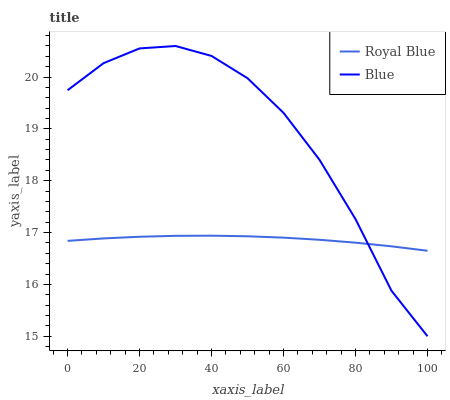Does Royal Blue have the minimum area under the curve?
Answer yes or no. Yes. Does Blue have the maximum area under the curve?
Answer yes or no. Yes. Does Royal Blue have the maximum area under the curve?
Answer yes or no. No. Is Royal Blue the smoothest?
Answer yes or no. Yes. Is Blue the roughest?
Answer yes or no. Yes. Is Royal Blue the roughest?
Answer yes or no. No. Does Blue have the lowest value?
Answer yes or no. Yes. Does Royal Blue have the lowest value?
Answer yes or no. No. Does Blue have the highest value?
Answer yes or no. Yes. Does Royal Blue have the highest value?
Answer yes or no. No. Does Royal Blue intersect Blue?
Answer yes or no. Yes. Is Royal Blue less than Blue?
Answer yes or no. No. Is Royal Blue greater than Blue?
Answer yes or no. No. 